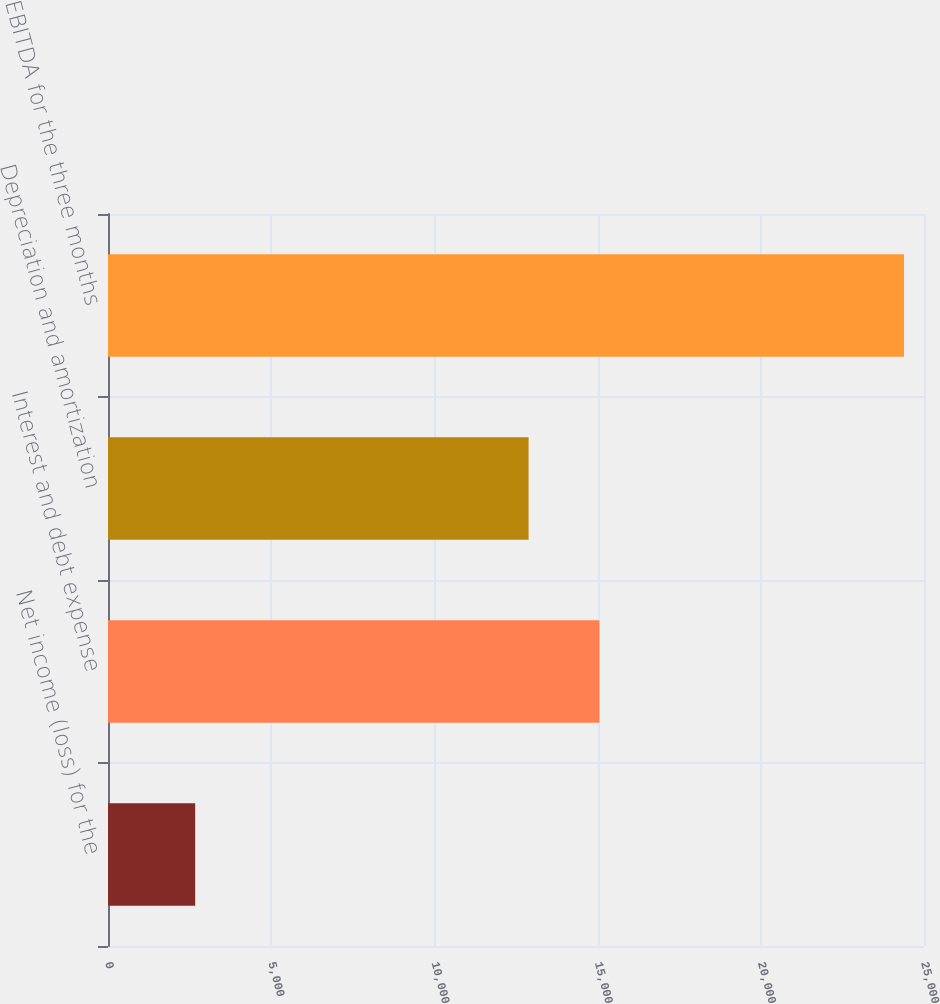<chart> <loc_0><loc_0><loc_500><loc_500><bar_chart><fcel>Net income (loss) for the<fcel>Interest and debt expense<fcel>Depreciation and amortization<fcel>EBITDA for the three months<nl><fcel>2671<fcel>15056.7<fcel>12885<fcel>24388<nl></chart> 